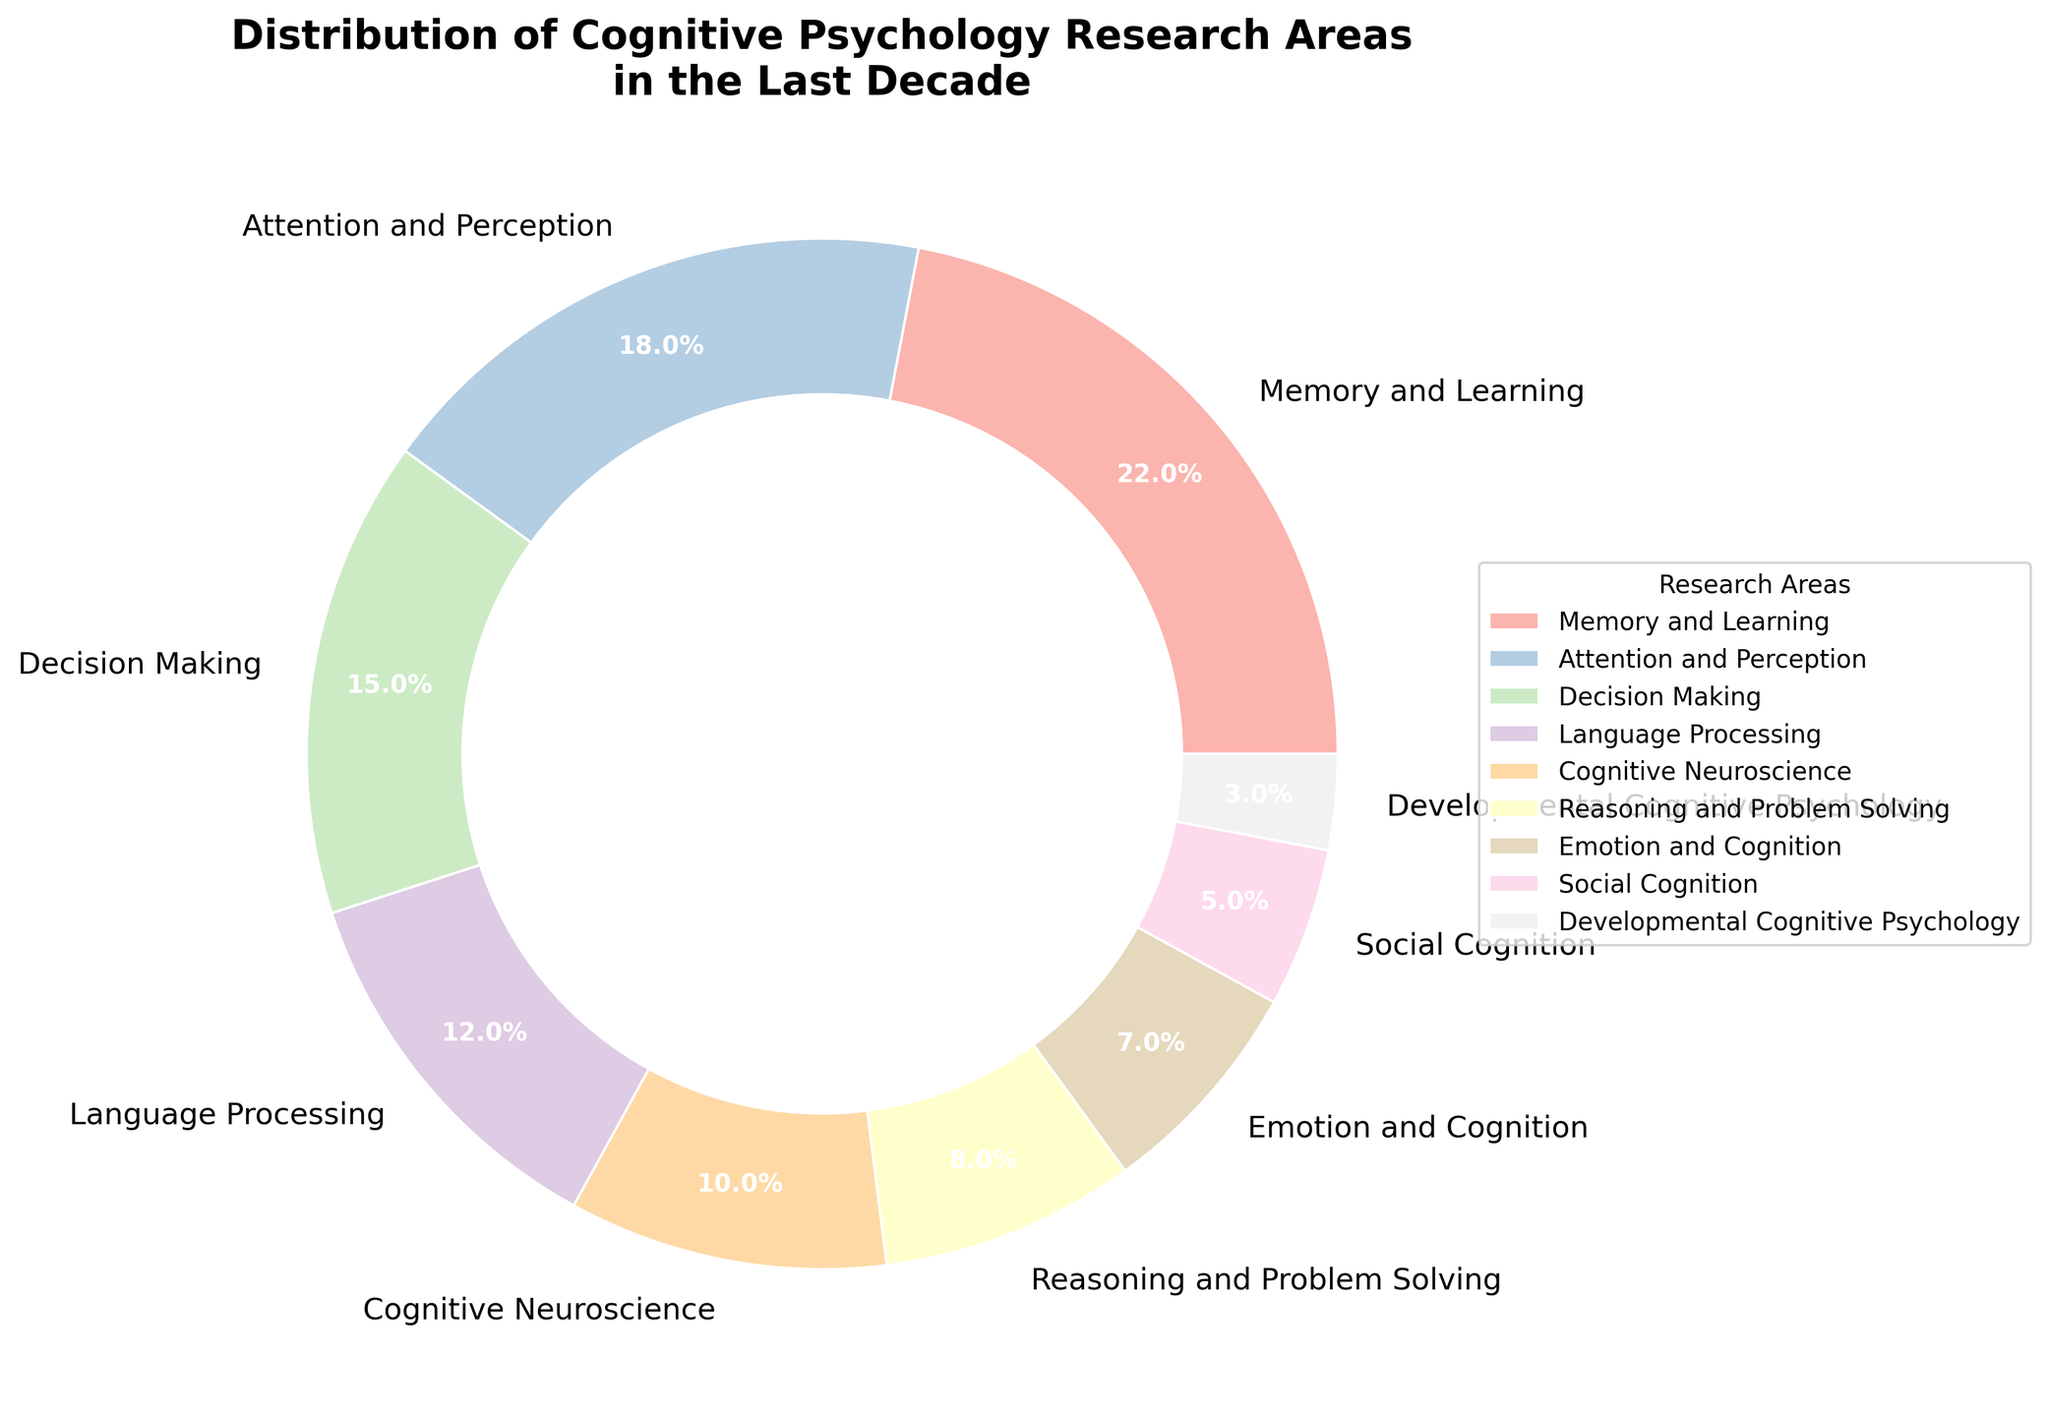What percentage of the research areas are focused on Memory and Learning and Decision Making combined? To find the combined percentage, add the percentages of Memory and Learning (22%) and Decision Making (15%). So, 22 + 15 = 37.
Answer: 37% Which research area has the highest percentage of focus? The research area with the highest percentage is Memory and Learning with 22%.
Answer: Memory and Learning Is the percentage of research focused on Cognitive Neuroscience greater than the percentage focused on Emotional and Cognition? The percentage for Cognitive Neuroscience is 10%, and for Emotion and Cognition is 7%, so 10% is greater than 7%.
Answer: Yes What is the difference in percentage between Attention and Perception and Social Cognition? Subtract the percentage for Social Cognition (5%) from the percentage for Attention and Perception (18%). So, 18 - 5 = 13.
Answer: 13% How does the distribution of Attention and Perception compare to Language Processing? Attention and Perception has a higher percentage (18%) than Language Processing (12%).
Answer: Attention and Perception is higher What fraction of the total research is focused on Reasoning and Problem Solving, Emotion and Cognition, and Social Cognition combined? Sum the percentages for Reasoning and Problem Solving (8%), Emotion and Cognition (7%), and Social Cognition (5%). So, 8 + 7 + 5 = 20. The fraction is 20/100.
Answer: 1/5 Which research areas have a percentage below 10%? Areas with less than 10% are Reasoning and Problem Solving (8%), Emotion and Cognition (7%), Social Cognition (5%), and Developmental Cognitive Psychology (3%).
Answer: Four By how much is the research percentage of Developmental Cognitive Psychology lower than Memory and Learning? Subtract the percentage for Developmental Cognitive Psychology (3%) from that of Memory and Learning (22%). So, 22 - 3 = 19.
Answer: 19% If a research paper is randomly selected, what is the probability, as a percentage, that it is focused on Language Processing or Cognitive Neuroscience? Add the percentages for Language Processing (12%) and Cognitive Neuroscience (10%). So, 12 + 10 = 22.
Answer: 22% Does any research area have exactly half the percentage of Memory and Learning? If yes, which one? Memory and Learning has 22%. Half of 22% is 11%. No research area has 11%.
Answer: No 